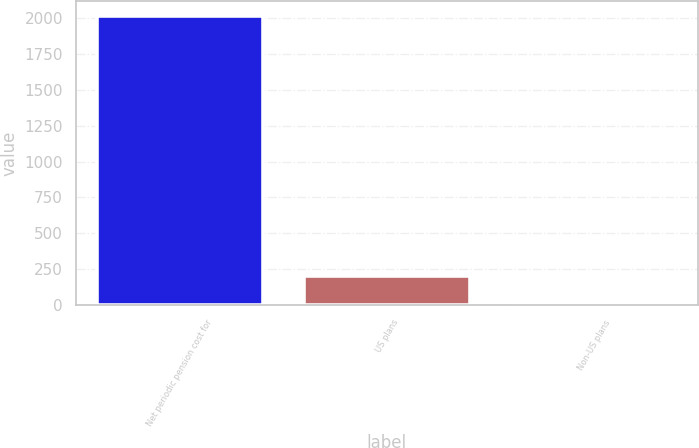<chart> <loc_0><loc_0><loc_500><loc_500><bar_chart><fcel>Net periodic pension cost for<fcel>US plans<fcel>Non-US plans<nl><fcel>2016<fcel>204.93<fcel>3.7<nl></chart> 